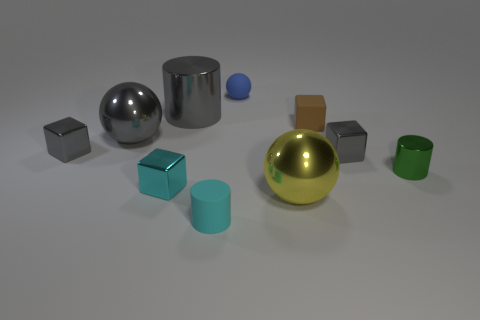Subtract all tiny metal blocks. How many blocks are left? 1 Subtract all large yellow balls. Subtract all purple matte cylinders. How many objects are left? 9 Add 7 matte balls. How many matte balls are left? 8 Add 6 green cylinders. How many green cylinders exist? 7 Subtract all green cylinders. How many cylinders are left? 2 Subtract 1 blue balls. How many objects are left? 9 Subtract all cubes. How many objects are left? 6 Subtract 3 spheres. How many spheres are left? 0 Subtract all red spheres. Subtract all red cylinders. How many spheres are left? 3 Subtract all red cylinders. How many yellow balls are left? 1 